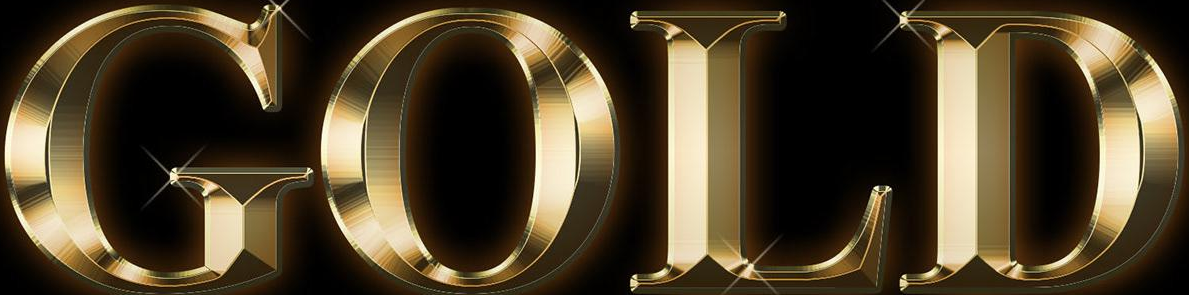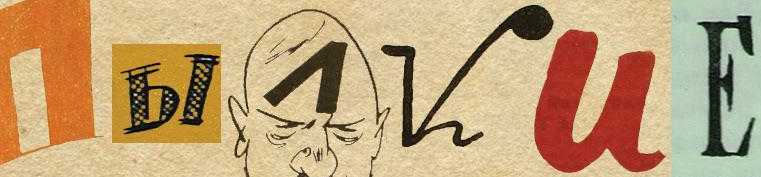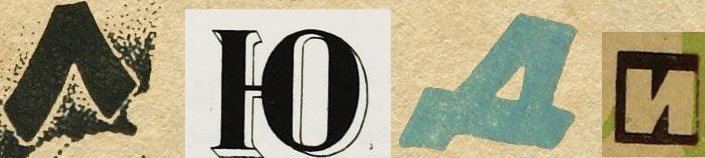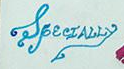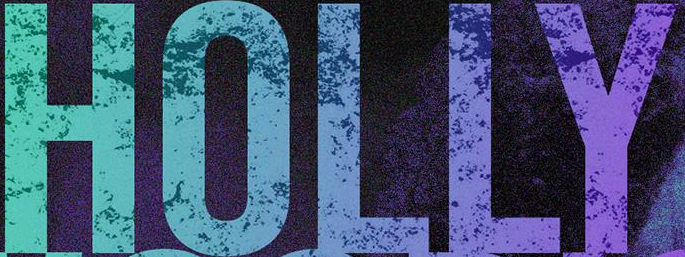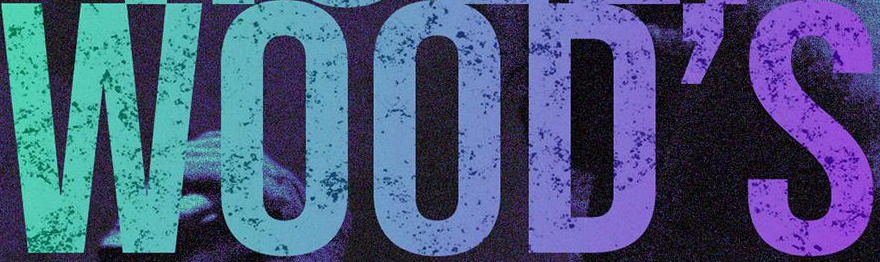What text appears in these images from left to right, separated by a semicolon? GOLD; I##VUЕ; ####; SpecIALLy; HOLLY; WOOD'S 